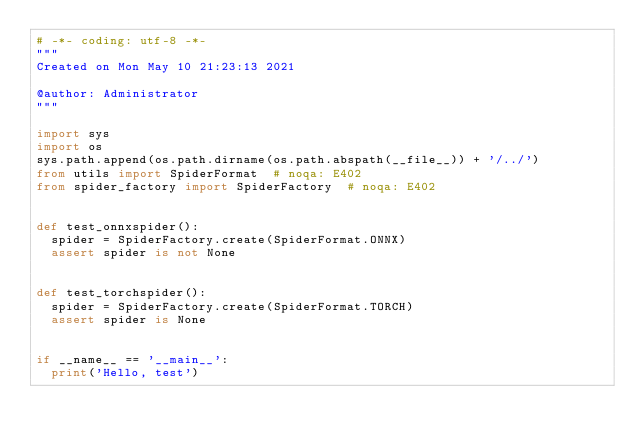Convert code to text. <code><loc_0><loc_0><loc_500><loc_500><_Python_># -*- coding: utf-8 -*-
"""
Created on Mon May 10 21:23:13 2021

@author: Administrator
"""

import sys
import os
sys.path.append(os.path.dirname(os.path.abspath(__file__)) + '/../')
from utils import SpiderFormat  # noqa: E402
from spider_factory import SpiderFactory  # noqa: E402


def test_onnxspider():
  spider = SpiderFactory.create(SpiderFormat.ONNX)
  assert spider is not None


def test_torchspider():
  spider = SpiderFactory.create(SpiderFormat.TORCH)
  assert spider is None


if __name__ == '__main__':
  print('Hello, test')</code> 